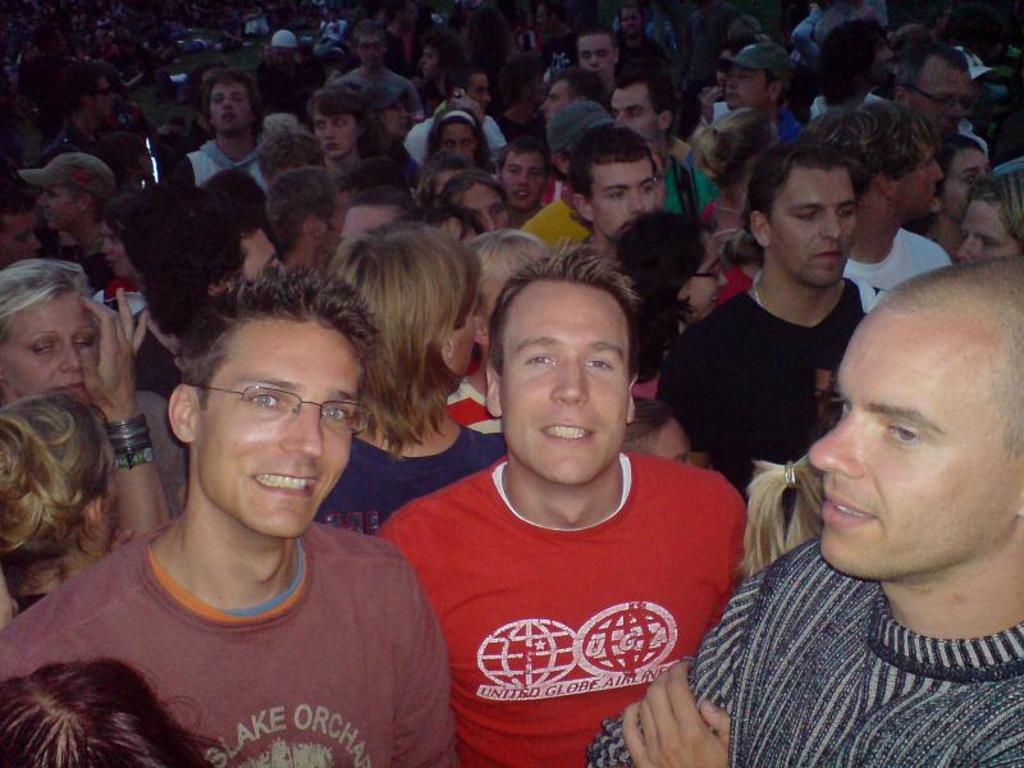How many people are present in the image? There are multiple people in the image. Can you describe the expressions of the people in the image? Some people in the image are smiling. What type of accessory is worn by at least one person in the image? At least one person in the image is wearing glasses (specs). What type of clothing is worn by most people in the image? Most people in the image are wearing t-shirts. What type of credit card is visible in the image? There is no credit card present in the image. Can you tell me how many baseballs are being held by the people in the image? There are no baseballs visible in the image. Is there a straw present in the image? There is no straw present in the image. 